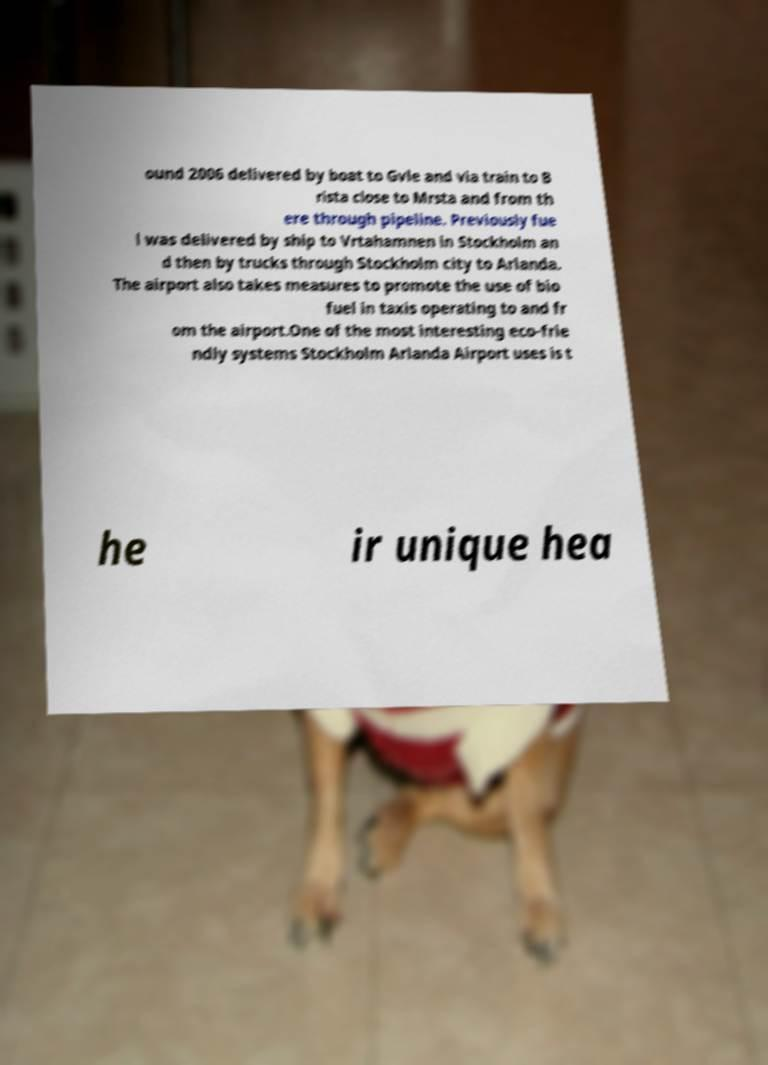For documentation purposes, I need the text within this image transcribed. Could you provide that? ound 2006 delivered by boat to Gvle and via train to B rista close to Mrsta and from th ere through pipeline. Previously fue l was delivered by ship to Vrtahamnen in Stockholm an d then by trucks through Stockholm city to Arlanda. The airport also takes measures to promote the use of bio fuel in taxis operating to and fr om the airport.One of the most interesting eco-frie ndly systems Stockholm Arlanda Airport uses is t he ir unique hea 